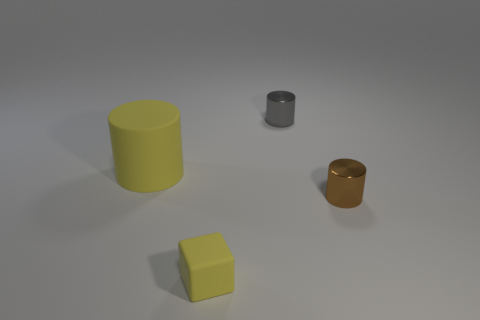Subtract all tiny metallic cylinders. How many cylinders are left? 1 Add 3 large brown matte balls. How many objects exist? 7 Subtract 1 cylinders. How many cylinders are left? 2 Add 4 brown objects. How many brown objects exist? 5 Subtract 0 red cubes. How many objects are left? 4 Subtract all cylinders. How many objects are left? 1 Subtract all green cylinders. Subtract all green cubes. How many cylinders are left? 3 Subtract all brown metallic objects. Subtract all blue metallic objects. How many objects are left? 3 Add 3 small yellow cubes. How many small yellow cubes are left? 4 